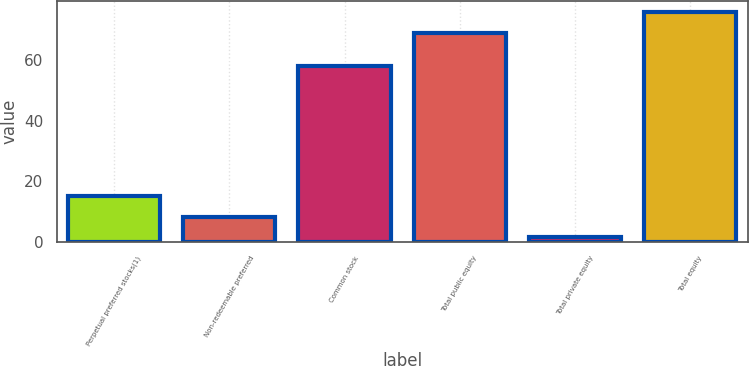<chart> <loc_0><loc_0><loc_500><loc_500><bar_chart><fcel>Perpetual preferred stocks(1)<fcel>Non-redeemable preferred<fcel>Common stock<fcel>Total public equity<fcel>Total private equity<fcel>Total equity<nl><fcel>15.03<fcel>8.28<fcel>58<fcel>69<fcel>1.53<fcel>75.75<nl></chart> 